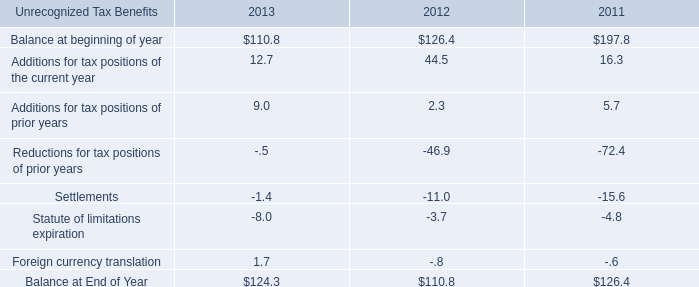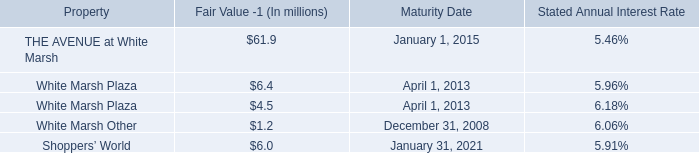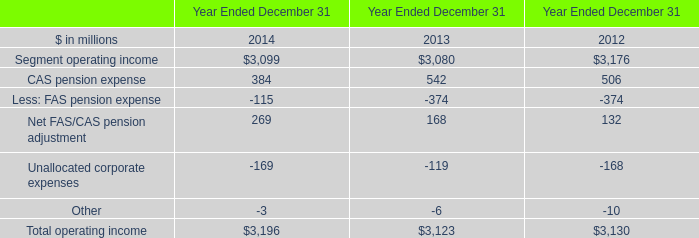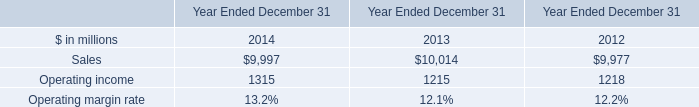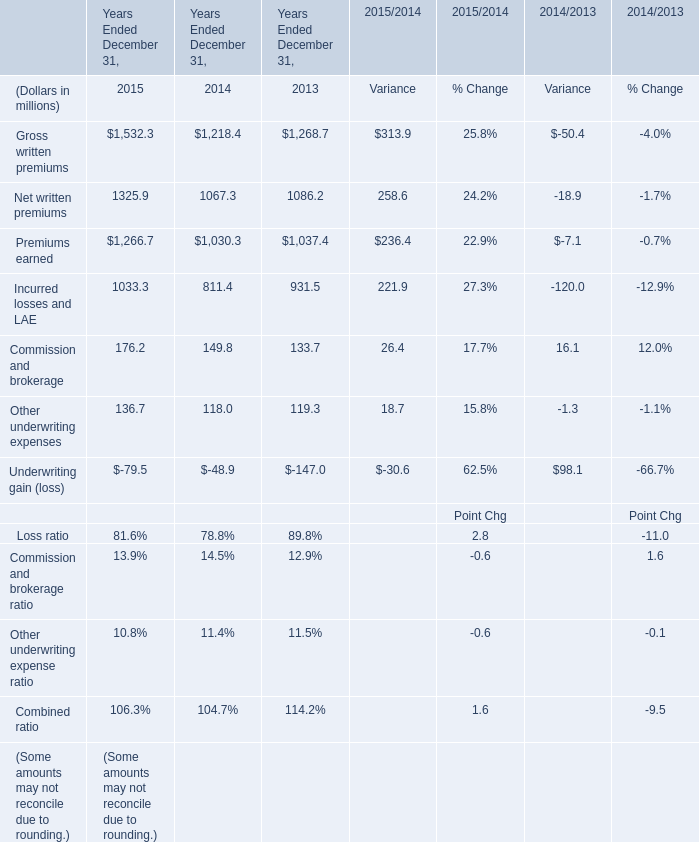What's the average of Segment operating income of Year Ended December 31 2013, and Premiums earned of Years Ended December 31, 2015 ? 
Computations: ((3080.0 + 1266.7) / 2)
Answer: 2173.35. 